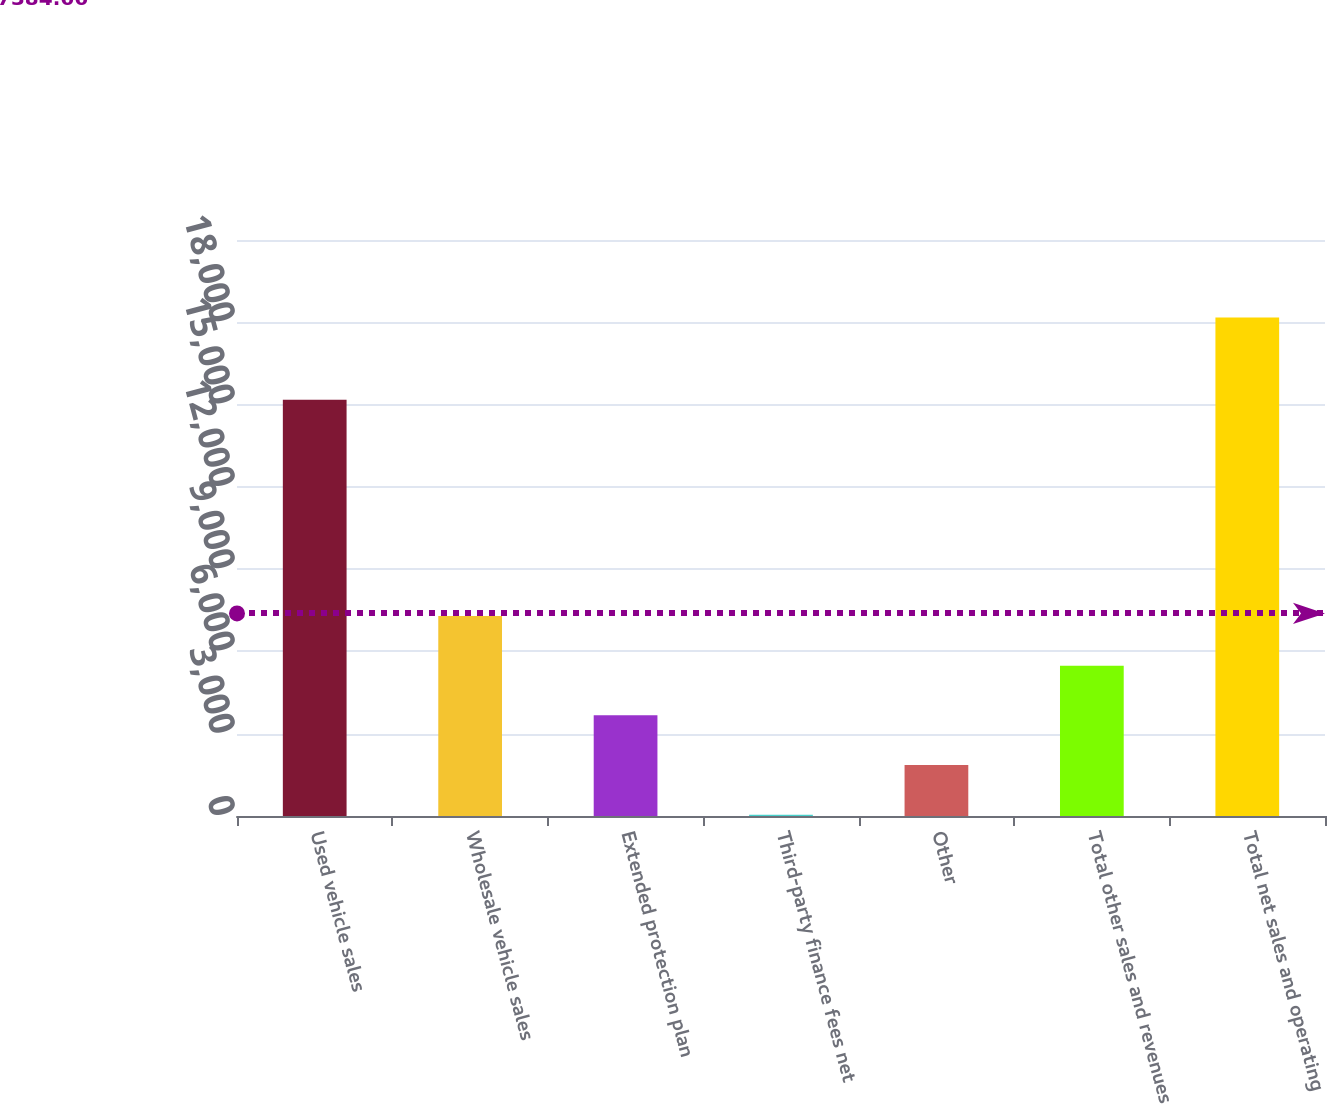<chart> <loc_0><loc_0><loc_500><loc_500><bar_chart><fcel>Used vehicle sales<fcel>Wholesale vehicle sales<fcel>Extended protection plan<fcel>Third-party finance fees net<fcel>Other<fcel>Total other sales and revenues<fcel>Total net sales and operating<nl><fcel>15172.8<fcel>7295.28<fcel>3669.34<fcel>43.4<fcel>1856.37<fcel>5482.31<fcel>18173.1<nl></chart> 